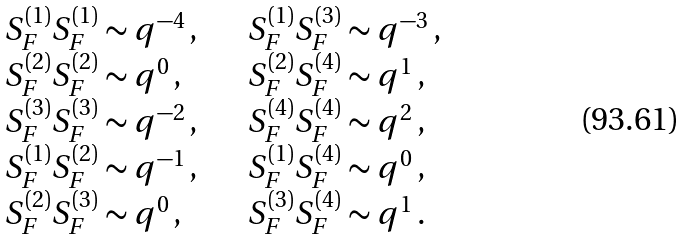<formula> <loc_0><loc_0><loc_500><loc_500>\begin{array} { l l l l } S _ { F } ^ { ( 1 ) } S _ { F } ^ { ( 1 ) } \sim q ^ { - 4 } \, , & & & S _ { F } ^ { ( 1 ) } S _ { F } ^ { ( 3 ) } \sim q ^ { - 3 } \, , \\ S _ { F } ^ { ( 2 ) } S _ { F } ^ { ( 2 ) } \sim q ^ { 0 } \, , & & & S _ { F } ^ { ( 2 ) } S _ { F } ^ { ( 4 ) } \sim q ^ { 1 } \, , \\ S _ { F } ^ { ( 3 ) } S _ { F } ^ { ( 3 ) } \sim q ^ { - 2 } \, , & & & S _ { F } ^ { ( 4 ) } S _ { F } ^ { ( 4 ) } \sim q ^ { 2 } \, , \\ S _ { F } ^ { ( 1 ) } S _ { F } ^ { ( 2 ) } \sim q ^ { - 1 } \, , & & & S _ { F } ^ { ( 1 ) } S _ { F } ^ { ( 4 ) } \sim q ^ { 0 } \, , \\ S _ { F } ^ { ( 2 ) } S _ { F } ^ { ( 3 ) } \sim q ^ { 0 } \, , & & & S _ { F } ^ { ( 3 ) } S _ { F } ^ { ( 4 ) } \sim q ^ { 1 } \, . \\ \end{array}</formula> 